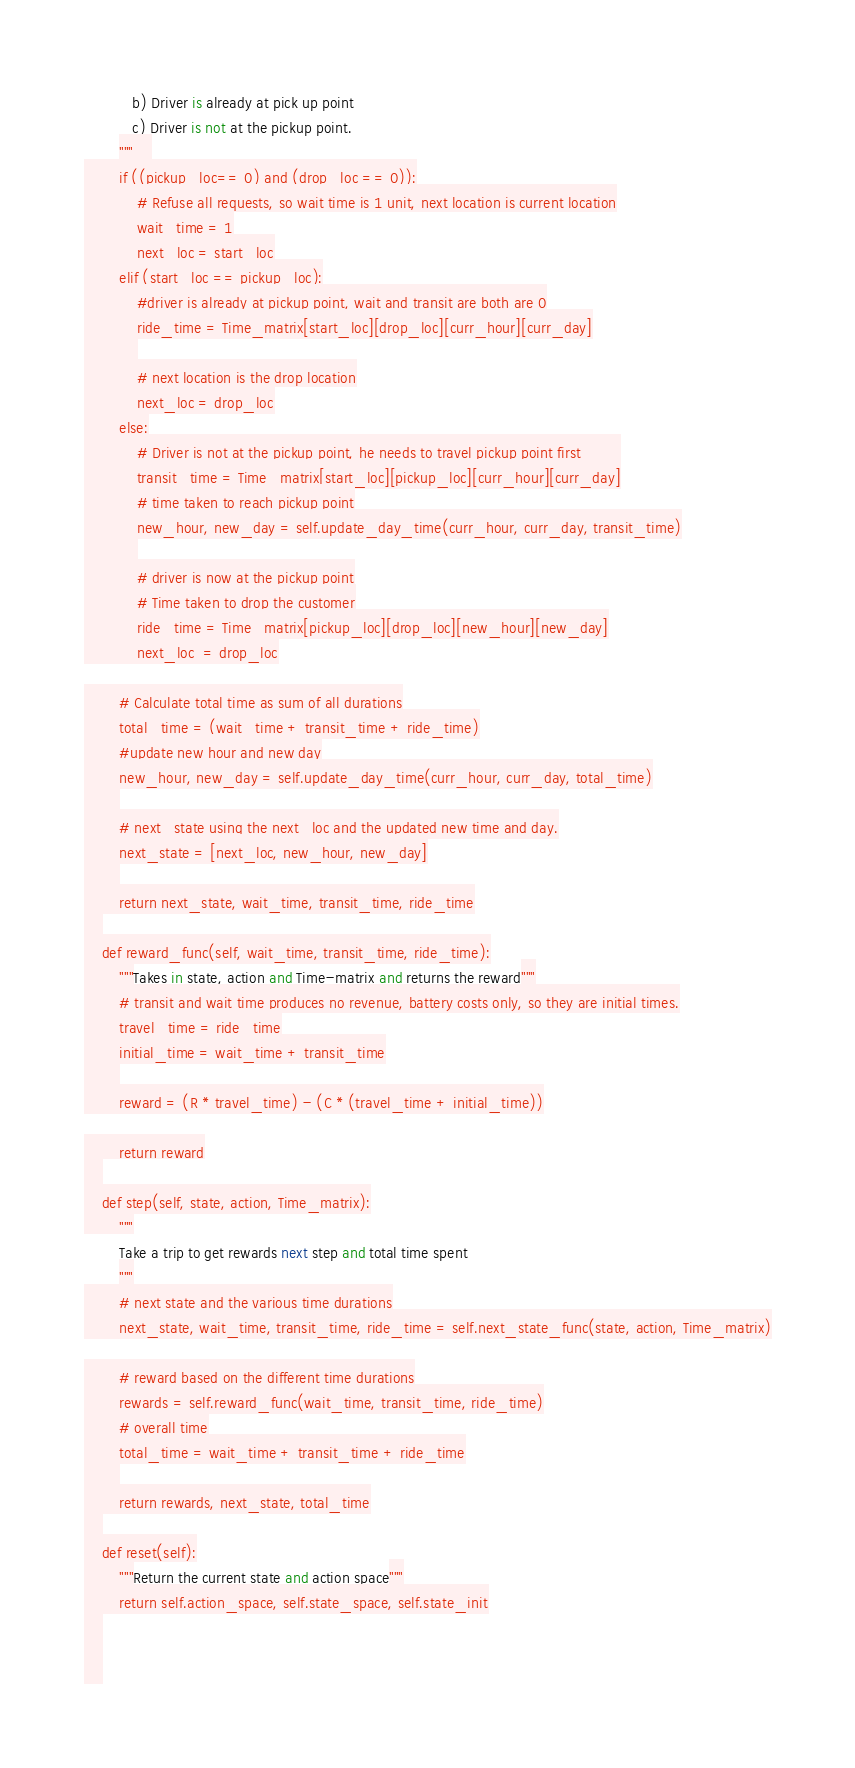<code> <loc_0><loc_0><loc_500><loc_500><_Python_>           b) Driver is already at pick up point
           c) Driver is not at the pickup point.
        """    
        if ((pickup_loc== 0) and (drop_loc == 0)):
            # Refuse all requests, so wait time is 1 unit, next location is current location
            wait_time = 1
            next_loc = start_loc
        elif (start_loc == pickup_loc):
            #driver is already at pickup point, wait and transit are both are 0
            ride_time = Time_matrix[start_loc][drop_loc][curr_hour][curr_day]
            
            # next location is the drop location
            next_loc = drop_loc
        else:
            # Driver is not at the pickup point, he needs to travel pickup point first         
            transit_time = Time_matrix[start_loc][pickup_loc][curr_hour][curr_day]
            # time taken to reach pickup point
            new_hour, new_day = self.update_day_time(curr_hour, curr_day, transit_time)
            
            # driver is now at the pickup point
            # Time taken to drop the customer
            ride_time = Time_matrix[pickup_loc][drop_loc][new_hour][new_day]
            next_loc  = drop_loc

        # Calculate total time as sum of all durations
        total_time = (wait_time + transit_time + ride_time)
        #update new hour and new day
        new_hour, new_day = self.update_day_time(curr_hour, curr_day, total_time)
        
        # next_state using the next_loc and the updated new time and day.
        next_state = [next_loc, new_hour, new_day]
        
        return next_state, wait_time, transit_time, ride_time
    
    def reward_func(self, wait_time, transit_time, ride_time):
        """Takes in state, action and Time-matrix and returns the reward"""
        # transit and wait time produces no revenue, battery costs only, so they are initial times.
        travel_time = ride_time
        initial_time = wait_time + transit_time
        
        reward = (R * travel_time) - (C * (travel_time + initial_time))

        return reward
    
    def step(self, state, action, Time_matrix):
        """
        Take a trip to get rewards next step and total time spent
        """
        # next state and the various time durations
        next_state, wait_time, transit_time, ride_time = self.next_state_func(state, action, Time_matrix)

        # reward based on the different time durations
        rewards = self.reward_func(wait_time, transit_time, ride_time)
        # overall time
        total_time = wait_time + transit_time + ride_time
        
        return rewards, next_state, total_time
    
    def reset(self):
        """Return the current state and action space"""
        return self.action_space, self.state_space, self.state_init
    
    
    </code> 